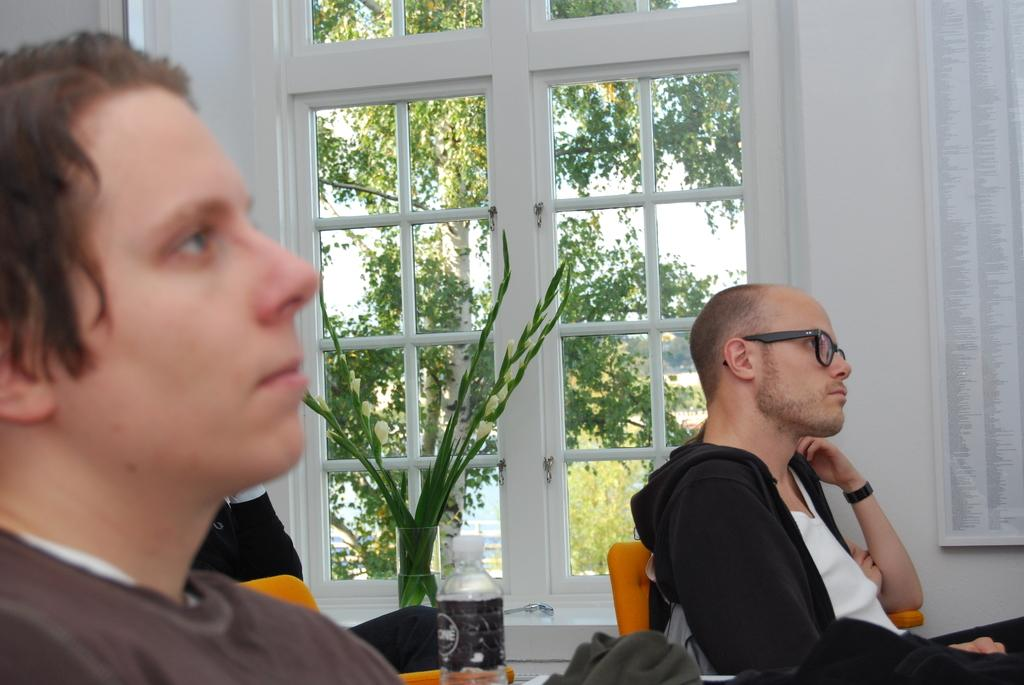What are the people in the image doing? The people in the image are sitting on chairs. What can be seen on the table in the image? There is a bottle and a plant in a glass on the table in the image. What is the purpose of the glass windows in the image? The glass windows allow for visibility of the trees and sky outside. What is the function of the curtain in the image? The curtain is associated with the glass windows, likely for privacy or light control. What is the background of the image? The background of the image includes a wall, trees, and the sky, which are visible through the glass windows. What type of cough is the person in the image experiencing? There is no indication in the image that anyone is experiencing a cough. What religious belief is represented by the plant in the glass? The image does not contain any information about religious beliefs, and the plant in the glass is not associated with any specific belief system. 